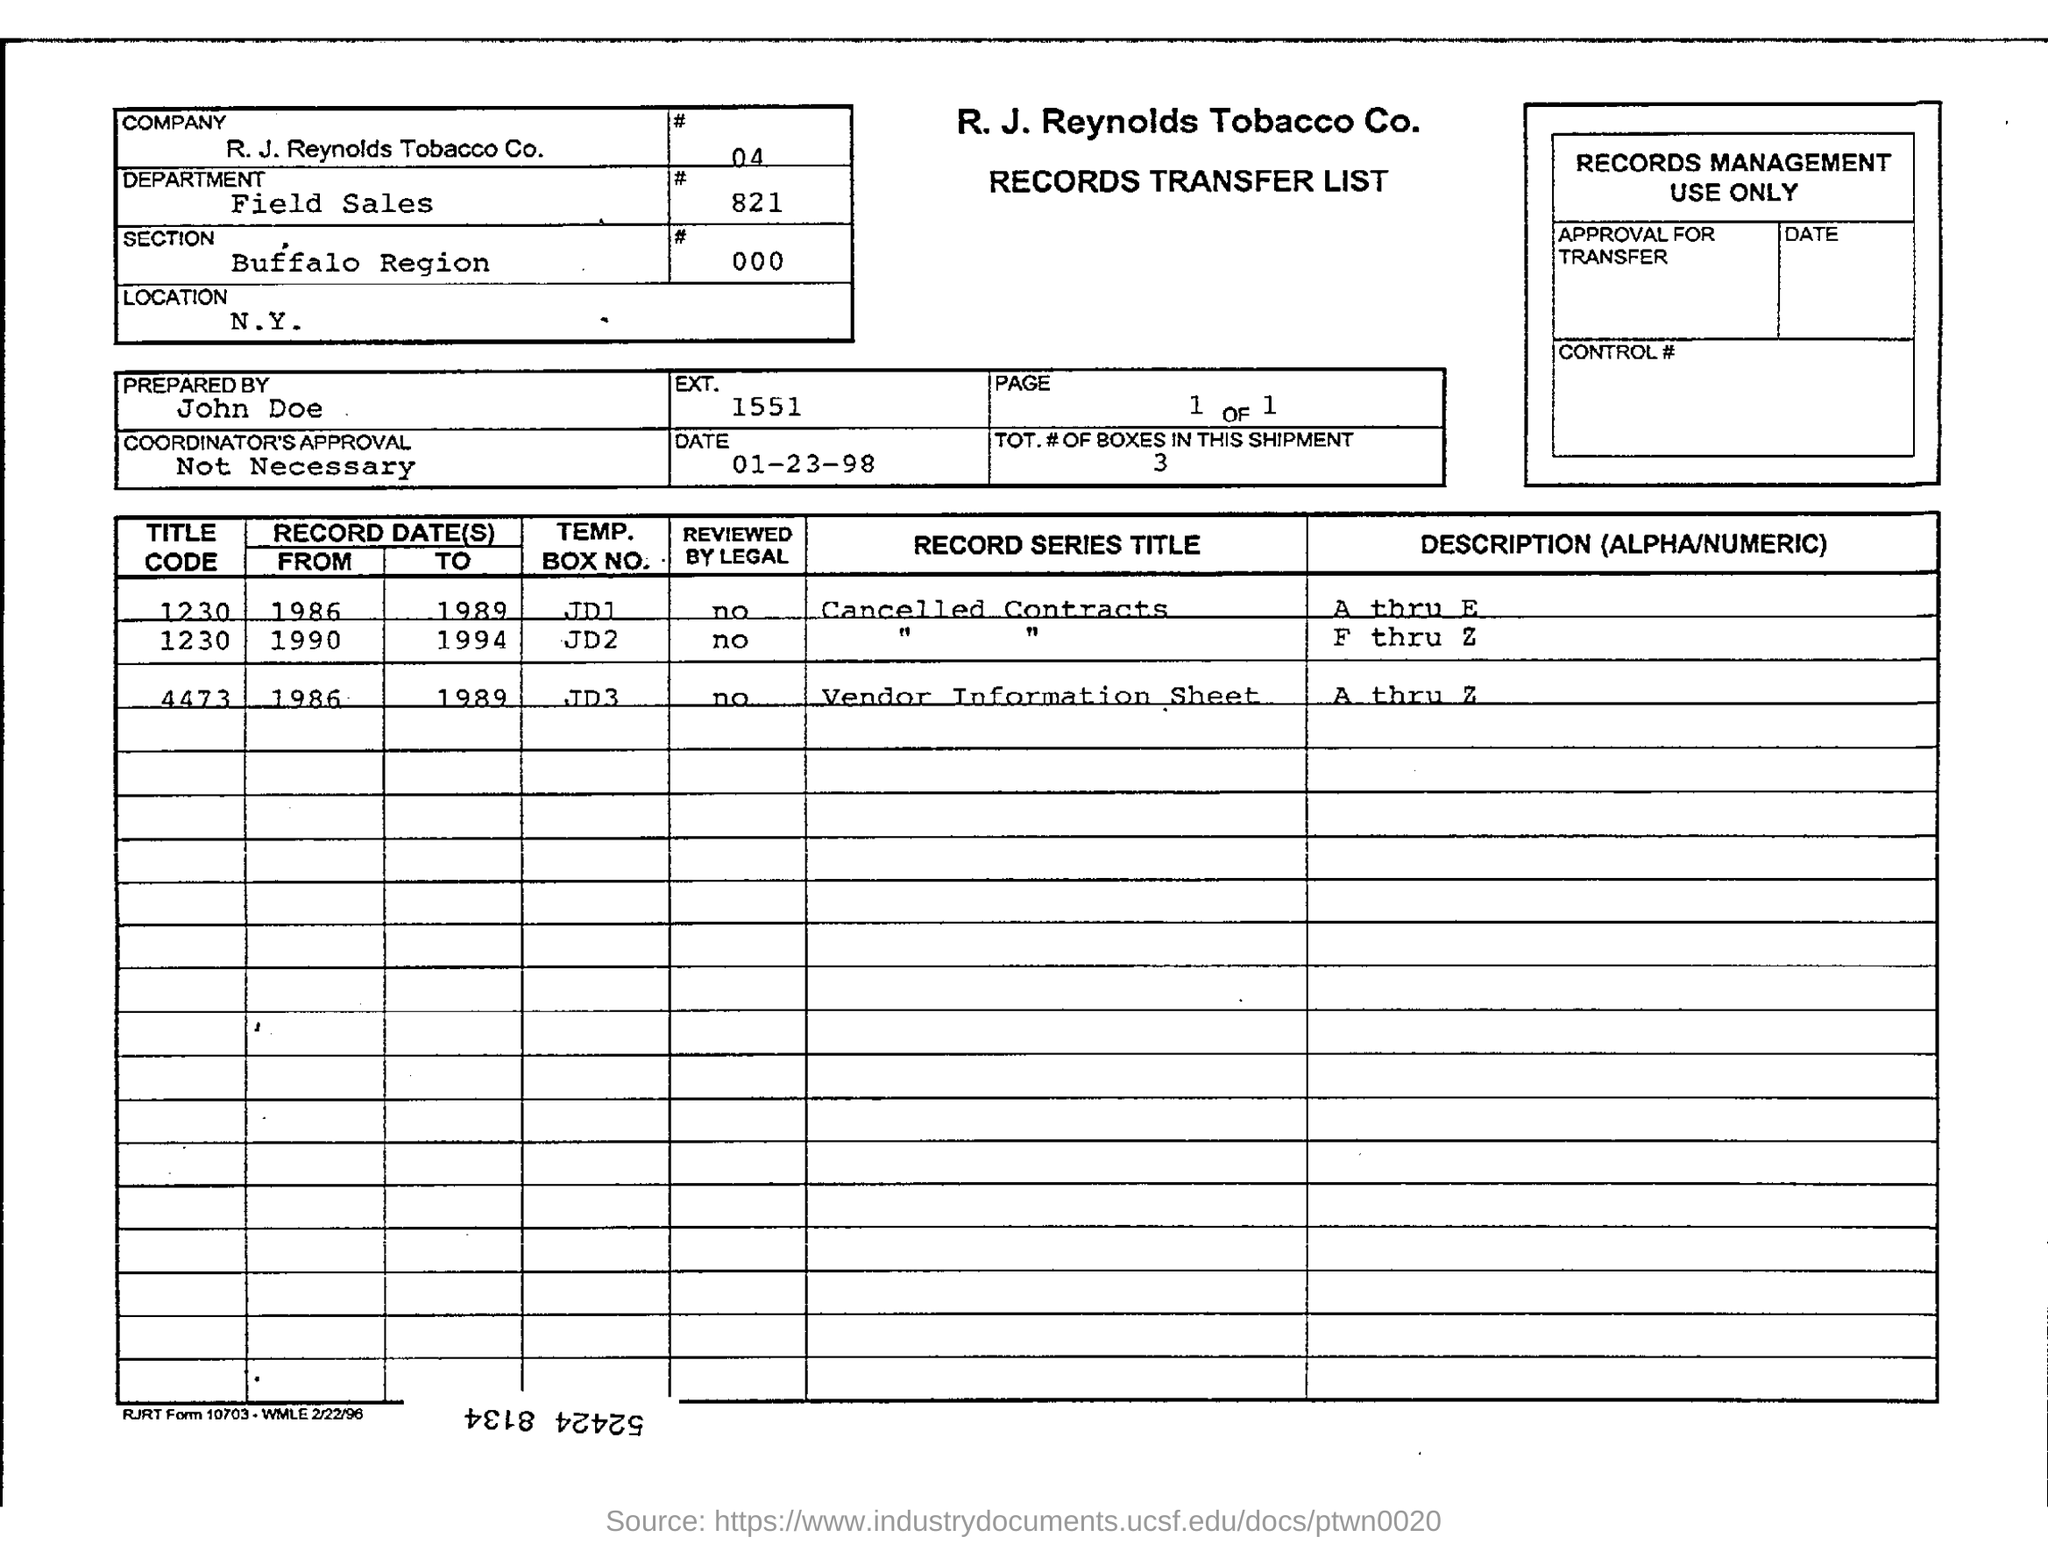Indicate a few pertinent items in this graphic. The date on the document is January 23, 1998. The section in question is located within the Buffalo region. The Department field sales... The preparation of this document was carried out by John Doe. The location is New York. 